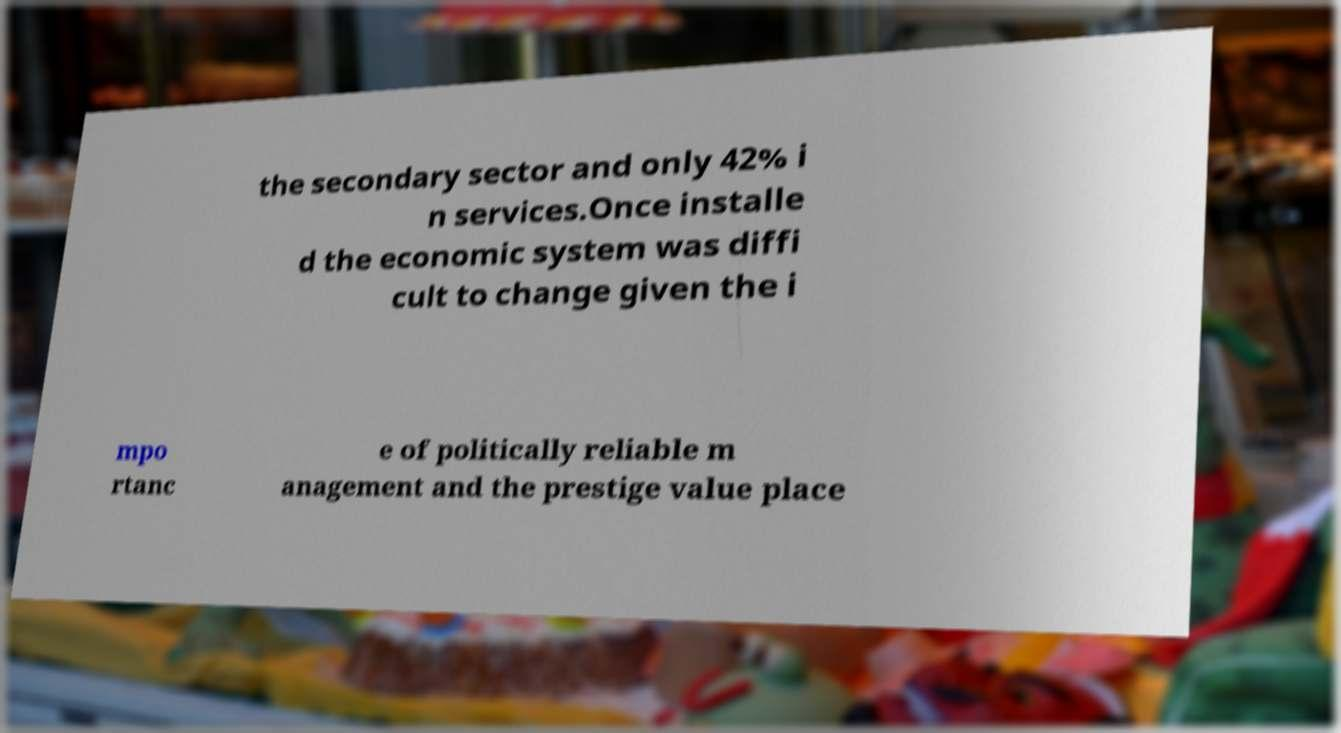Please read and relay the text visible in this image. What does it say? the secondary sector and only 42% i n services.Once installe d the economic system was diffi cult to change given the i mpo rtanc e of politically reliable m anagement and the prestige value place 